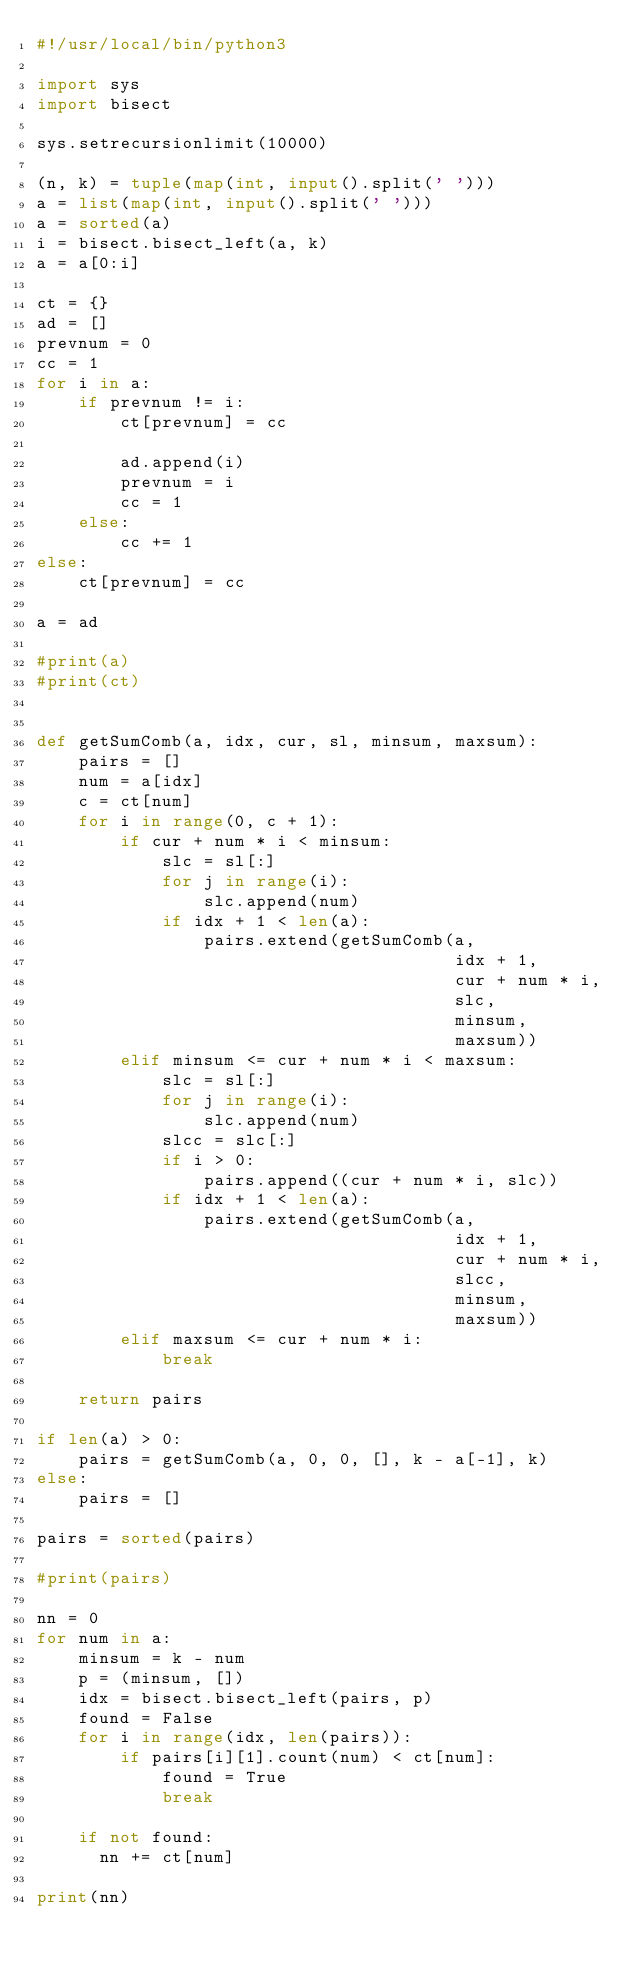<code> <loc_0><loc_0><loc_500><loc_500><_Python_>#!/usr/local/bin/python3

import sys
import bisect

sys.setrecursionlimit(10000)

(n, k) = tuple(map(int, input().split(' ')))
a = list(map(int, input().split(' ')))
a = sorted(a)
i = bisect.bisect_left(a, k)
a = a[0:i]

ct = {}
ad = []
prevnum = 0
cc = 1
for i in a:
    if prevnum != i:
        ct[prevnum] = cc

        ad.append(i)
        prevnum = i
        cc = 1
    else:
        cc += 1
else:
    ct[prevnum] = cc

a = ad

#print(a)
#print(ct)


def getSumComb(a, idx, cur, sl, minsum, maxsum):
    pairs = []
    num = a[idx]
    c = ct[num]
    for i in range(0, c + 1):
        if cur + num * i < minsum:
            slc = sl[:]            
            for j in range(i):
                slc.append(num)
            if idx + 1 < len(a):
                pairs.extend(getSumComb(a,
                                        idx + 1,
                                        cur + num * i,
                                        slc,
                                        minsum,
                                        maxsum))                 
        elif minsum <= cur + num * i < maxsum:
            slc = sl[:]
            for j in range(i):
                slc.append(num)
            slcc = slc[:]
            if i > 0:
                pairs.append((cur + num * i, slc))
            if idx + 1 < len(a):
                pairs.extend(getSumComb(a,
                                        idx + 1,
                                        cur + num * i,
                                        slcc,
                                        minsum,
                                        maxsum))
        elif maxsum <= cur + num * i:
            break
    
    return pairs

if len(a) > 0:
    pairs = getSumComb(a, 0, 0, [], k - a[-1], k)
else:
    pairs = []
    
pairs = sorted(pairs)

#print(pairs)

nn = 0
for num in a:
    minsum = k - num
    p = (minsum, [])
    idx = bisect.bisect_left(pairs, p)
    found = False
    for i in range(idx, len(pairs)):
        if pairs[i][1].count(num) < ct[num]:
            found = True
            break

    if not found:
      nn += ct[num]  

print(nn)
</code> 